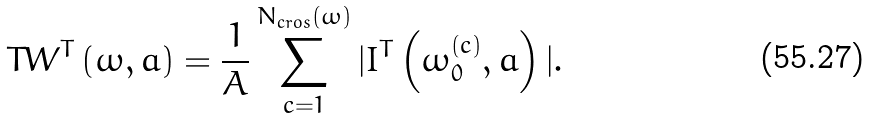Convert formula to latex. <formula><loc_0><loc_0><loc_500><loc_500>T W ^ { T } \left ( \omega , a \right ) = \frac { 1 } { A } \sum _ { c = 1 } ^ { N _ { c r o s } ( \omega ) } | I ^ { T } \left ( \omega _ { 0 } ^ { ( c ) } , a \right ) | .</formula> 